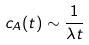<formula> <loc_0><loc_0><loc_500><loc_500>c _ { A } ( t ) \sim \frac { 1 } { \lambda t }</formula> 